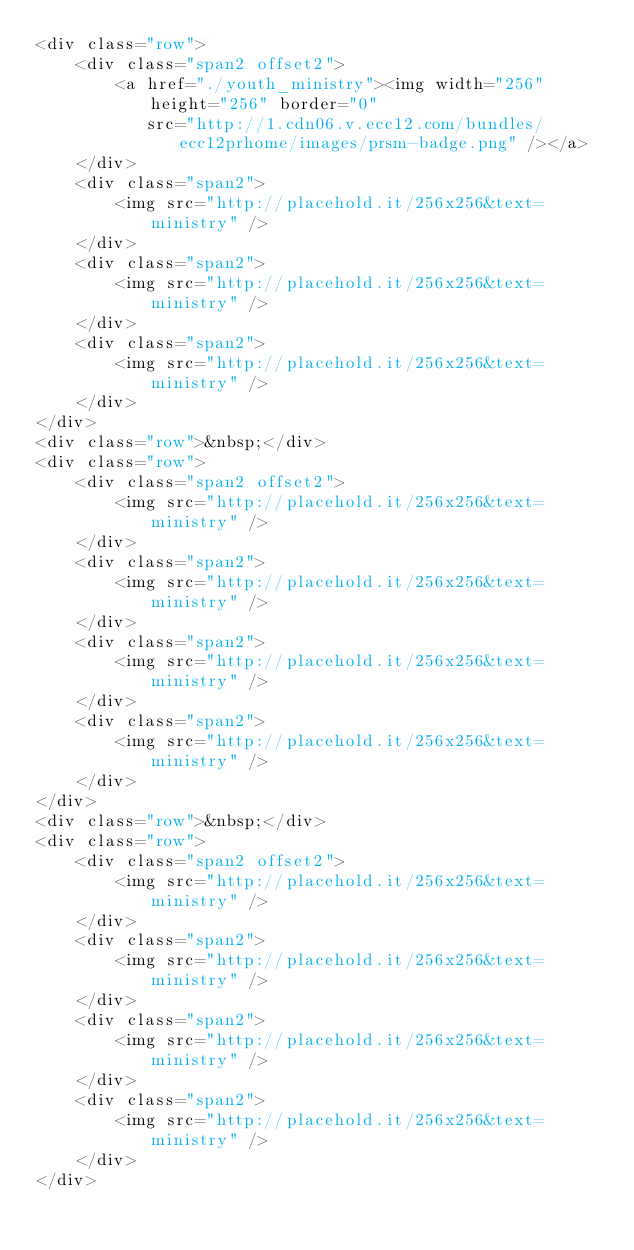<code> <loc_0><loc_0><loc_500><loc_500><_HTML_><div class="row">
    <div class="span2 offset2">
        <a href="./youth_ministry"><img width="256" height="256" border="0"
           src="http://1.cdn06.v.ecc12.com/bundles/ecc12prhome/images/prsm-badge.png" /></a>
    </div>
    <div class="span2">
        <img src="http://placehold.it/256x256&text=ministry" />
    </div>
    <div class="span2">
        <img src="http://placehold.it/256x256&text=ministry" />
    </div>
    <div class="span2">
        <img src="http://placehold.it/256x256&text=ministry" />
    </div>
</div>
<div class="row">&nbsp;</div>
<div class="row">
    <div class="span2 offset2">
        <img src="http://placehold.it/256x256&text=ministry" />
    </div>
    <div class="span2">
        <img src="http://placehold.it/256x256&text=ministry" />
    </div>
    <div class="span2">
        <img src="http://placehold.it/256x256&text=ministry" />
    </div>
    <div class="span2">
        <img src="http://placehold.it/256x256&text=ministry" />
    </div>
</div>
<div class="row">&nbsp;</div>
<div class="row">
    <div class="span2 offset2">
        <img src="http://placehold.it/256x256&text=ministry" />
    </div>
    <div class="span2">
        <img src="http://placehold.it/256x256&text=ministry" />
    </div>
    <div class="span2">
        <img src="http://placehold.it/256x256&text=ministry" />
    </div>
    <div class="span2">
        <img src="http://placehold.it/256x256&text=ministry" />
    </div>
</div>
</code> 